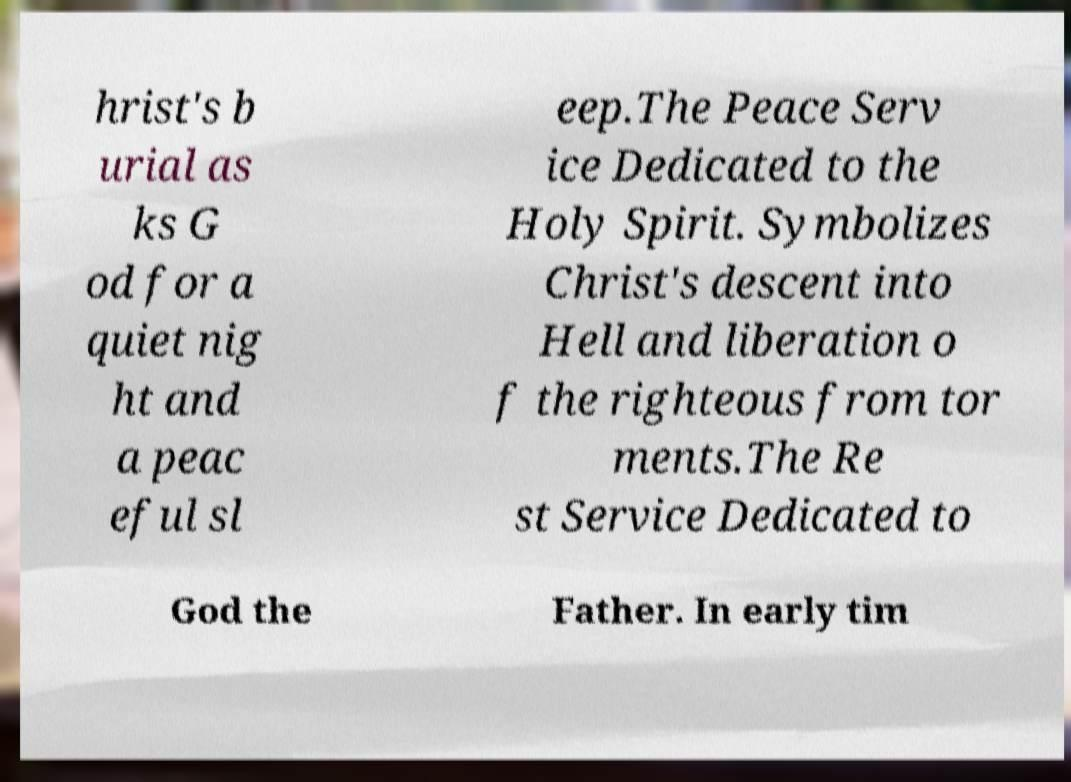Please identify and transcribe the text found in this image. hrist's b urial as ks G od for a quiet nig ht and a peac eful sl eep.The Peace Serv ice Dedicated to the Holy Spirit. Symbolizes Christ's descent into Hell and liberation o f the righteous from tor ments.The Re st Service Dedicated to God the Father. In early tim 